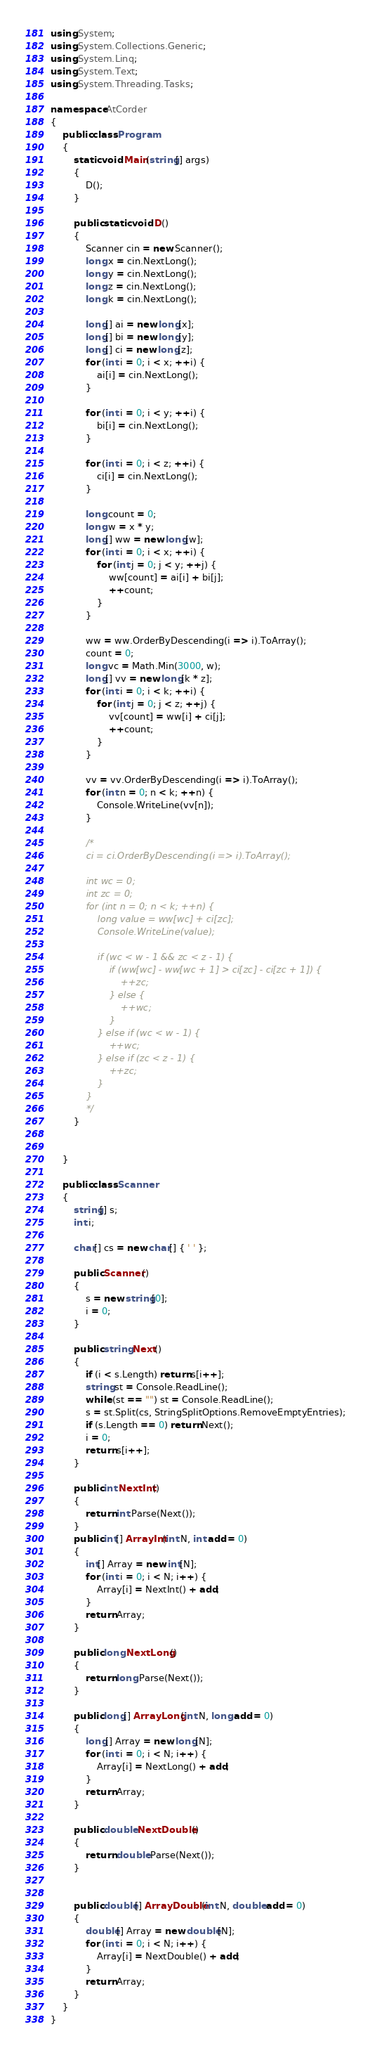Convert code to text. <code><loc_0><loc_0><loc_500><loc_500><_C#_>using System;
using System.Collections.Generic;
using System.Linq;
using System.Text;
using System.Threading.Tasks;

namespace AtCorder
{
	public class Program
	{
		static void Main(string[] args)
		{
			D();
		}

		public static void D()
		{
			Scanner cin = new Scanner();
			long x = cin.NextLong();
			long y = cin.NextLong();
			long z = cin.NextLong();
			long k = cin.NextLong();

			long[] ai = new long[x];
			long[] bi = new long[y];
			long[] ci = new long[z];
			for (int i = 0; i < x; ++i) {
				ai[i] = cin.NextLong();
			}

			for (int i = 0; i < y; ++i) {
				bi[i] = cin.NextLong();
			}

			for (int i = 0; i < z; ++i) {
				ci[i] = cin.NextLong();
			}

			long count = 0;
			long w = x * y;
			long[] ww = new long[w];
			for (int i = 0; i < x; ++i) {
				for (int j = 0; j < y; ++j) {
					ww[count] = ai[i] + bi[j];
					++count;
				}
			}

			ww = ww.OrderByDescending(i => i).ToArray();
			count = 0;
			long vc = Math.Min(3000, w);
			long[] vv = new long[k * z];
			for (int i = 0; i < k; ++i) {
				for (int j = 0; j < z; ++j) {
					vv[count] = ww[i] + ci[j];
					++count;
				}
			}

			vv = vv.OrderByDescending(i => i).ToArray();
			for (int n = 0; n < k; ++n) {
				Console.WriteLine(vv[n]);
			}

			/*
			ci = ci.OrderByDescending(i => i).ToArray();

			int wc = 0;
			int zc = 0;
			for (int n = 0; n < k; ++n) {
				long value = ww[wc] + ci[zc];
				Console.WriteLine(value);

				if (wc < w - 1 && zc < z - 1) {
					if (ww[wc] - ww[wc + 1] > ci[zc] - ci[zc + 1]) {
						++zc;
					} else {
						++wc;
					}
				} else if (wc < w - 1) {
					++wc;
				} else if (zc < z - 1) {
					++zc;
				}
			}
			*/
		}

		
	}

	public class Scanner
	{
		string[] s;
		int i;

		char[] cs = new char[] { ' ' };

		public Scanner()
		{
			s = new string[0];
			i = 0;
		}

		public string Next()
		{
			if (i < s.Length) return s[i++];
			string st = Console.ReadLine();
			while (st == "") st = Console.ReadLine();
			s = st.Split(cs, StringSplitOptions.RemoveEmptyEntries);
			if (s.Length == 0) return Next();
			i = 0;
			return s[i++];
		}

		public int NextInt()
		{
			return int.Parse(Next());
		}
		public int[] ArrayInt(int N, int add = 0)
		{
			int[] Array = new int[N];
			for (int i = 0; i < N; i++) {
				Array[i] = NextInt() + add;
			}
			return Array;
		}

		public long NextLong()
		{
			return long.Parse(Next());
		}

		public long[] ArrayLong(int N, long add = 0)
		{
			long[] Array = new long[N];
			for (int i = 0; i < N; i++) {
				Array[i] = NextLong() + add;
			}
			return Array;
		}

		public double NextDouble()
		{
			return double.Parse(Next());
		}


		public double[] ArrayDouble(int N, double add = 0)
		{
			double[] Array = new double[N];
			for (int i = 0; i < N; i++) {
				Array[i] = NextDouble() + add;
			}
			return Array;
		}
	}
}
</code> 